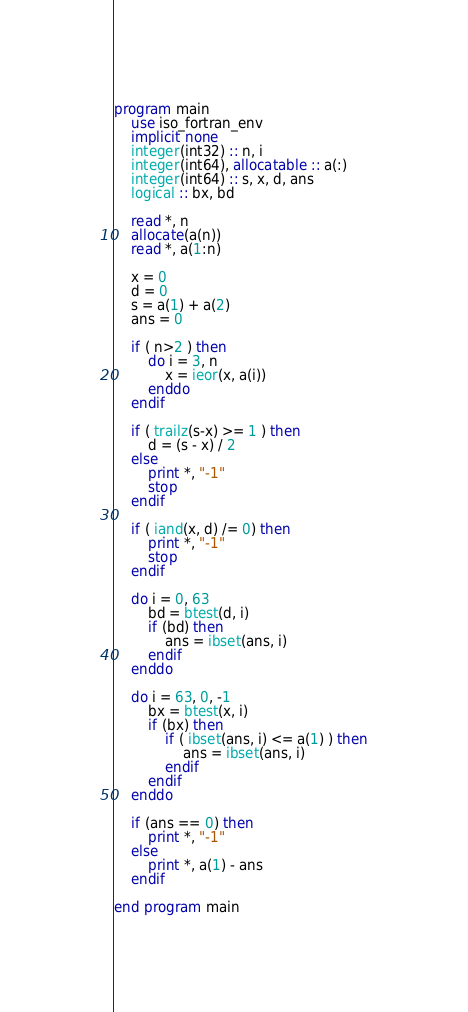<code> <loc_0><loc_0><loc_500><loc_500><_FORTRAN_>program main
    use iso_fortran_env
    implicit none
    integer(int32) :: n, i
    integer(int64), allocatable :: a(:)
    integer(int64) :: s, x, d, ans
    logical :: bx, bd

    read *, n
    allocate(a(n))
    read *, a(1:n)

    x = 0
    d = 0
    s = a(1) + a(2)
    ans = 0

    if ( n>2 ) then
        do i = 3, n
            x = ieor(x, a(i))
        enddo
    endif

    if ( trailz(s-x) >= 1 ) then
        d = (s - x) / 2
    else
        print *, "-1"
        stop
    endif

    if ( iand(x, d) /= 0) then
        print *, "-1"
        stop
    endif

    do i = 0, 63
        bd = btest(d, i)
        if (bd) then
            ans = ibset(ans, i)
        endif
    enddo

    do i = 63, 0, -1
        bx = btest(x, i)
        if (bx) then
            if ( ibset(ans, i) <= a(1) ) then
                ans = ibset(ans, i)
            endif
        endif
    enddo

    if (ans == 0) then
        print *, "-1"
    else
        print *, a(1) - ans
    endif

end program main
</code> 